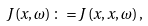Convert formula to latex. <formula><loc_0><loc_0><loc_500><loc_500>J \left ( x , \omega \right ) \colon = J \left ( x , x , \omega \right ) ,</formula> 